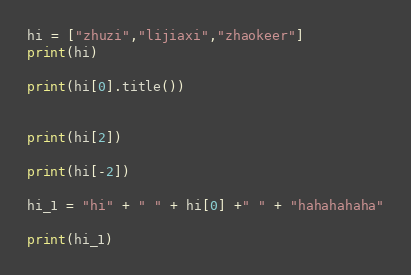Convert code to text. <code><loc_0><loc_0><loc_500><loc_500><_Python_>hi = ["zhuzi","lijiaxi","zhaokeer"]
print(hi)

print(hi[0].title())


print(hi[2])

print(hi[-2])

hi_1 = "hi" + " " + hi[0] +" " + "hahahahaha"

print(hi_1)</code> 